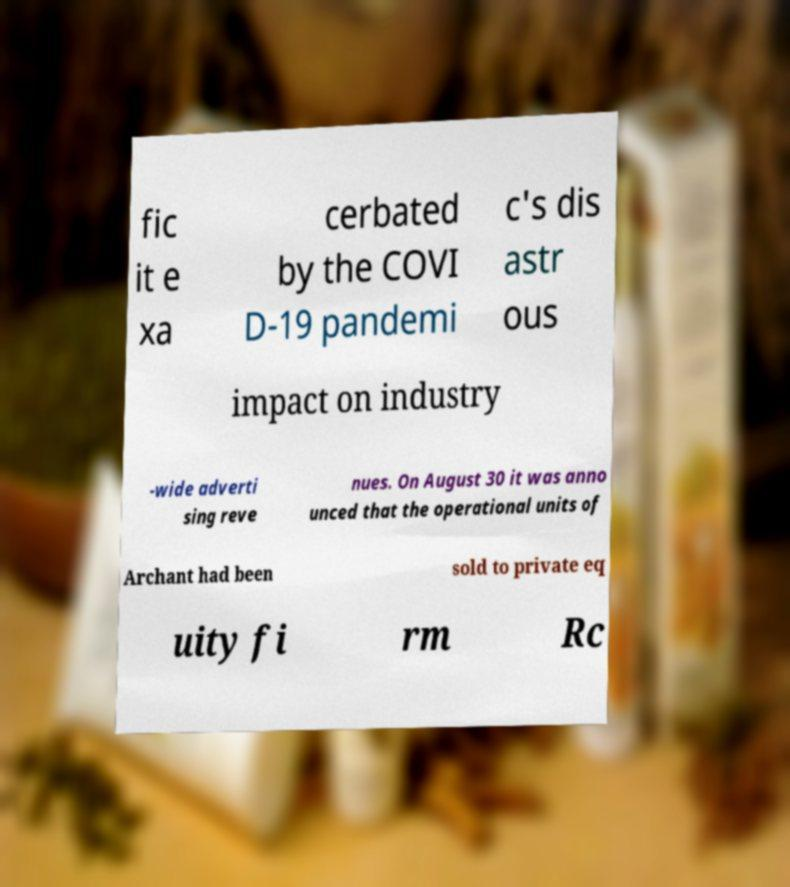Could you extract and type out the text from this image? fic it e xa cerbated by the COVI D-19 pandemi c's dis astr ous impact on industry -wide adverti sing reve nues. On August 30 it was anno unced that the operational units of Archant had been sold to private eq uity fi rm Rc 